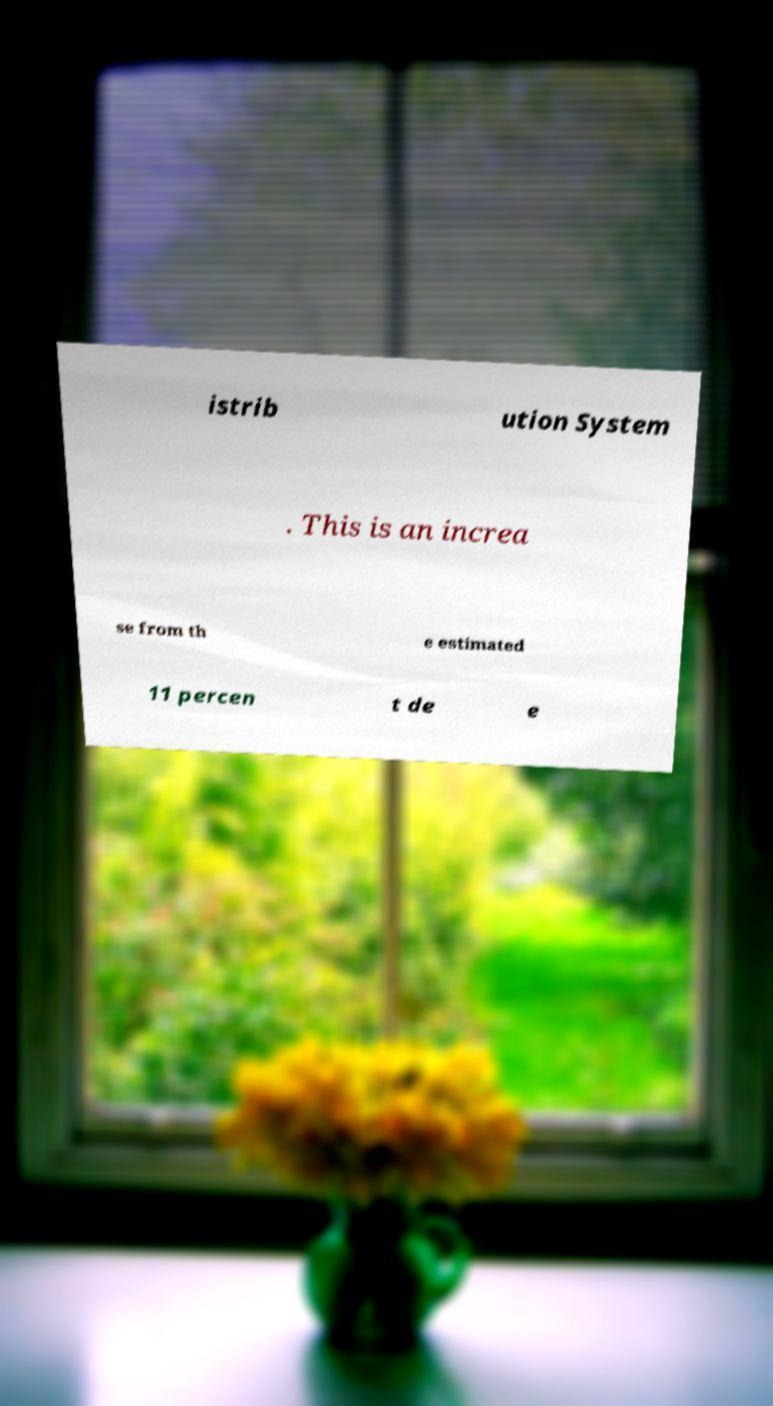Can you accurately transcribe the text from the provided image for me? istrib ution System . This is an increa se from th e estimated 11 percen t de e 